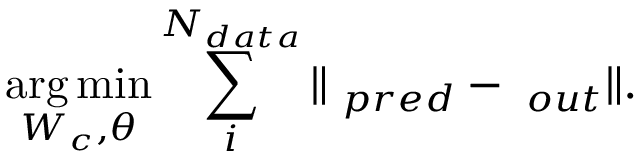<formula> <loc_0><loc_0><loc_500><loc_500>\arg \, \min _ { W _ { c } , \theta } \sum _ { i } ^ { N _ { d a t a } } \| \varphi _ { p r e d } - \varphi _ { o u t } \| .</formula> 